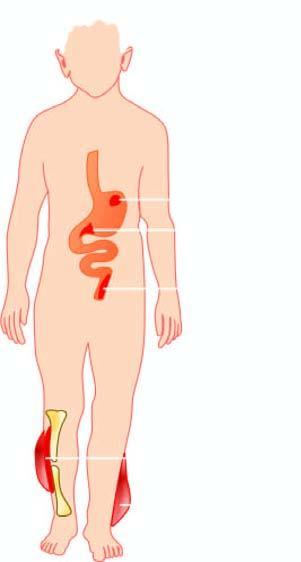s the tubular epithelial cells caused by clostridia?
Answer the question using a single word or phrase. No 